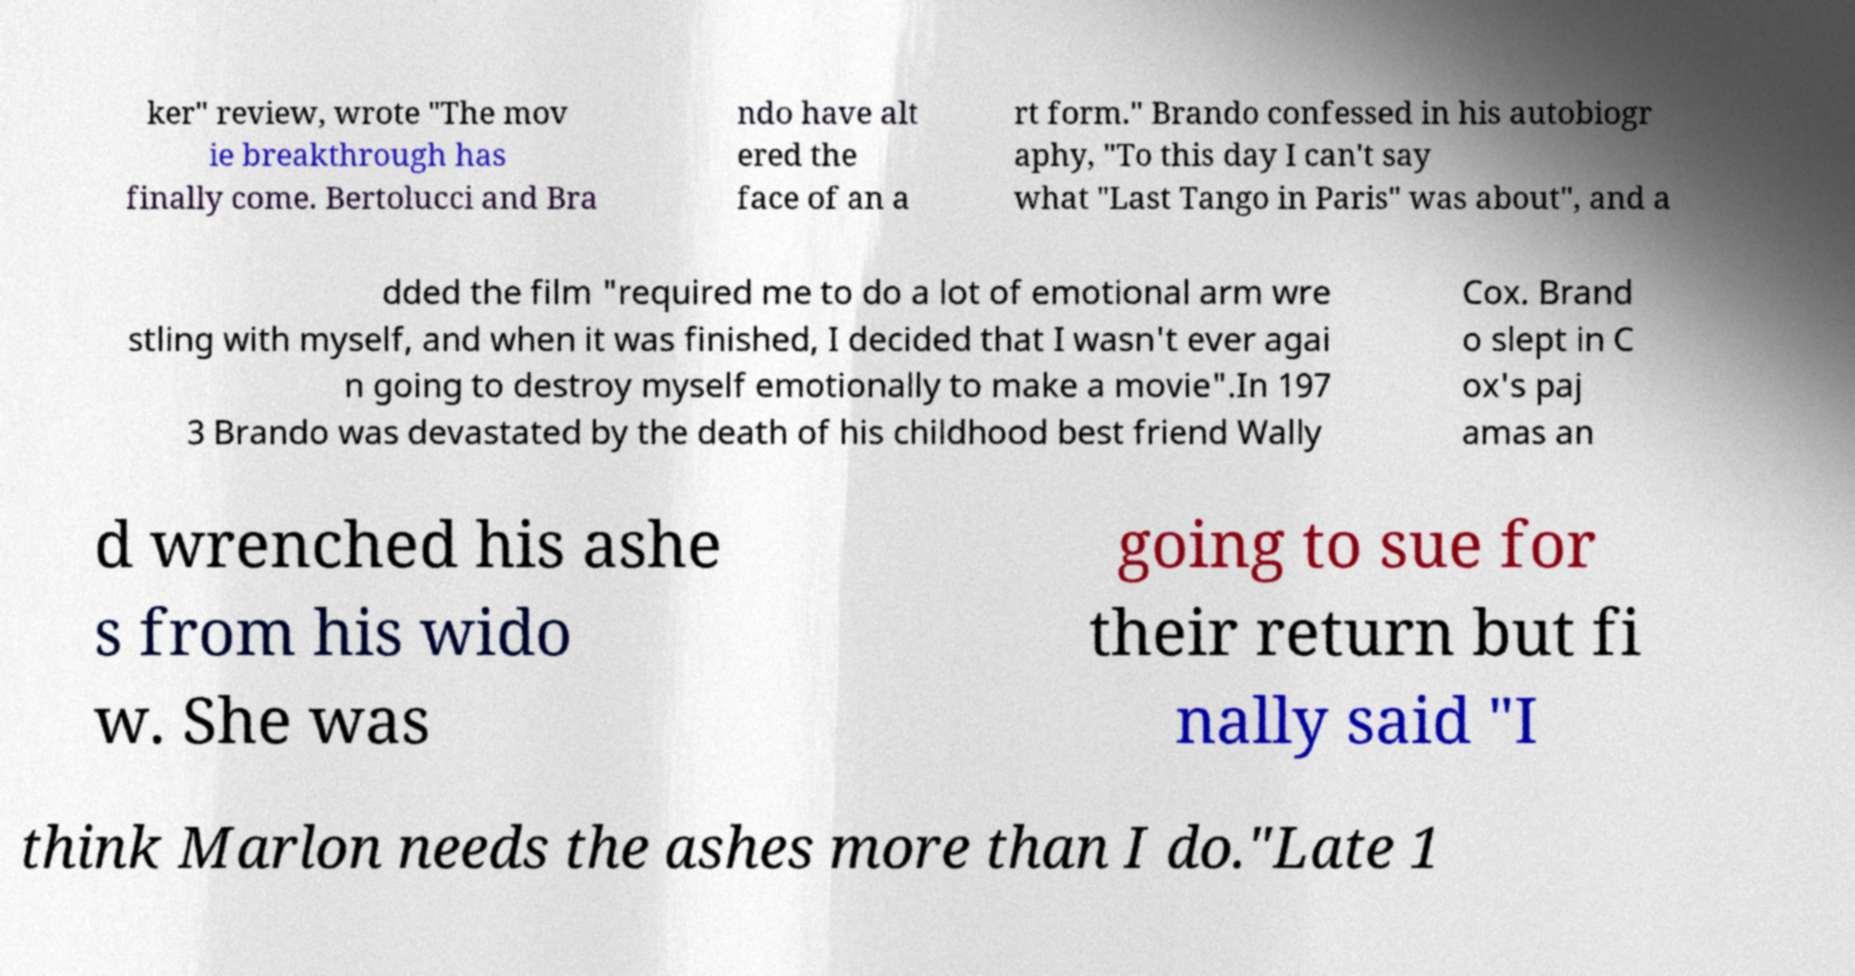For documentation purposes, I need the text within this image transcribed. Could you provide that? ker" review, wrote "The mov ie breakthrough has finally come. Bertolucci and Bra ndo have alt ered the face of an a rt form." Brando confessed in his autobiogr aphy, "To this day I can't say what "Last Tango in Paris" was about", and a dded the film "required me to do a lot of emotional arm wre stling with myself, and when it was finished, I decided that I wasn't ever agai n going to destroy myself emotionally to make a movie".In 197 3 Brando was devastated by the death of his childhood best friend Wally Cox. Brand o slept in C ox's paj amas an d wrenched his ashe s from his wido w. She was going to sue for their return but fi nally said "I think Marlon needs the ashes more than I do."Late 1 